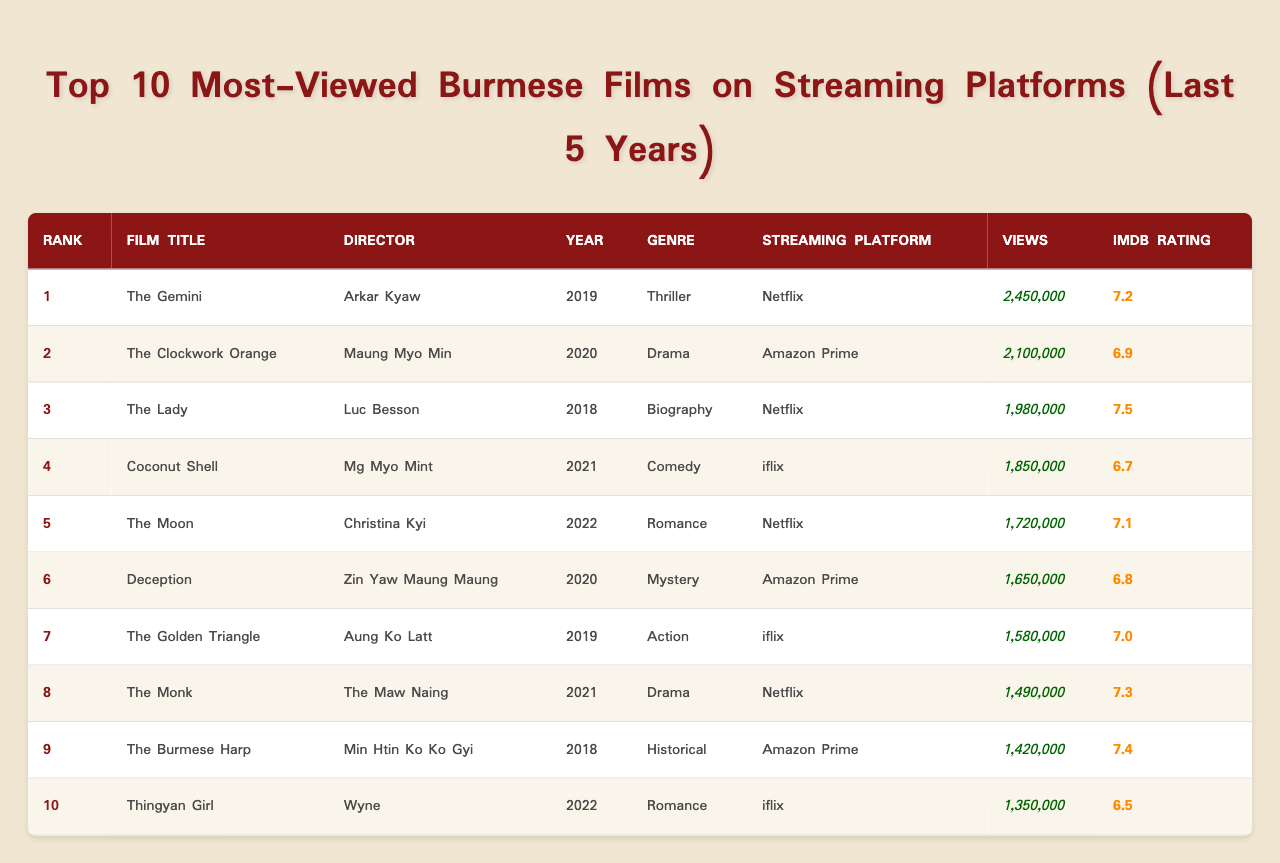What is the film with the highest number of views? The film "The Gemini" has the highest views with 2,450,000. It is located in the row for Rank 1 in the table.
Answer: The Gemini Which streaming platform has the most films in the top 10? Netflix has four films: "The Gemini," "The Lady," "The Moon," and "The Monk," as seen in the "Streaming Platform" column for these entries.
Answer: Netflix What is the average IMDb rating of the top 5 films? The ratings of the top 5 films are 7.2, 6.9, 7.5, 7.1, and 6.8. Adding these gives 35.5, and dividing by 5 gives an average of 7.1.
Answer: 7.1 Is "Coconut Shell" rated higher than "The Moon"? "Coconut Shell" has an IMDb rating of 6.7, whereas "The Moon" has a rating of 7.1. Since 6.7 is less than 7.1, the statement is false.
Answer: No How many views do the top 3 films have combined? The views are 2,450,000 for "The Gemini," 2,100,000 for "The Clockwork Orange," and 1,980,000 for "The Lady." Adding these gives a total of 6,530,000 views.
Answer: 6,530,000 Which genre is the most represented in the top 10? The genres in the table are Thriller, Drama, Biography, Comedy, Romance, Mystery, Action, Historical. Romance and Drama each appear twice in the list, as noted in their respective rows.
Answer: Romance and Drama What year did the film with the lowest views release? "Thingyan Girl" has the lowest views at 1,350,000 and it was released in 2022.
Answer: 2022 Is "The Burmese Harp" considered a biography film? "The Burmese Harp" is categorized under Historical genre, therefore it is not a biography film.
Answer: No What is the difference in views between "The Golden Triangle" and "The Monk"? "The Golden Triangle" has 1,580,000 views and "The Monk" has 1,490,000 views. The difference is 1,580,000 - 1,490,000 = 90,000.
Answer: 90,000 Which film has the highest IMDb rating in the bottom half of the table? In the bottom half (ranks 6-10), "The Monk" has the highest rating at 7.3. This is confirmed by looking at the ratings for the respective films.
Answer: The Monk 